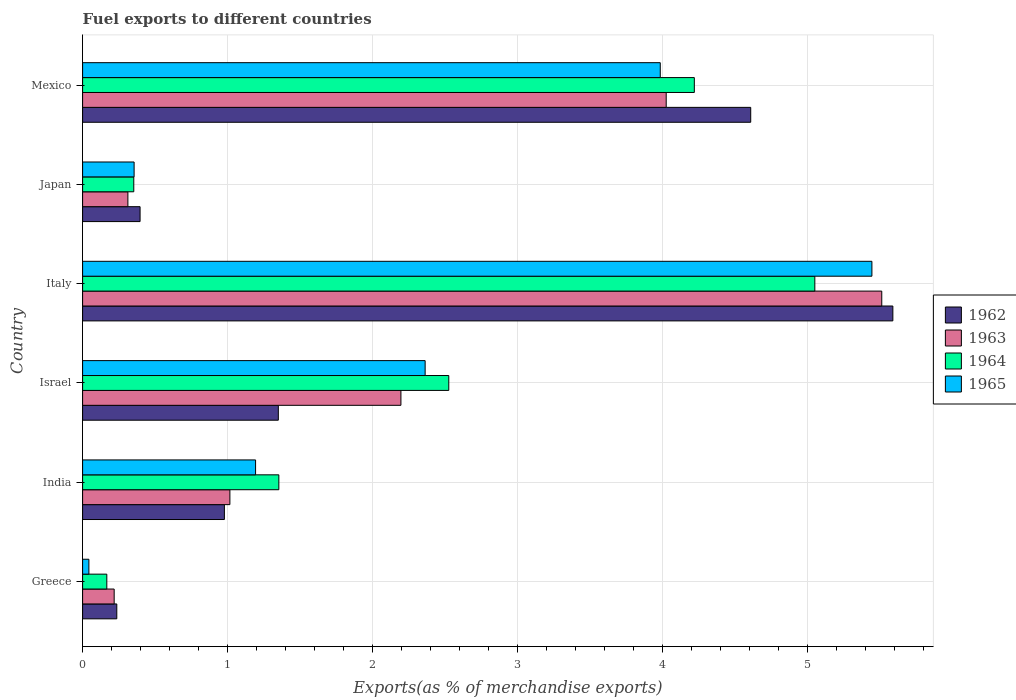How many different coloured bars are there?
Offer a very short reply. 4. How many groups of bars are there?
Offer a terse response. 6. Are the number of bars per tick equal to the number of legend labels?
Your response must be concise. Yes. How many bars are there on the 4th tick from the top?
Make the answer very short. 4. What is the label of the 1st group of bars from the top?
Offer a terse response. Mexico. In how many cases, is the number of bars for a given country not equal to the number of legend labels?
Your answer should be very brief. 0. What is the percentage of exports to different countries in 1965 in Japan?
Give a very brief answer. 0.36. Across all countries, what is the maximum percentage of exports to different countries in 1963?
Keep it short and to the point. 5.51. Across all countries, what is the minimum percentage of exports to different countries in 1964?
Your answer should be compact. 0.17. In which country was the percentage of exports to different countries in 1964 maximum?
Your answer should be very brief. Italy. What is the total percentage of exports to different countries in 1963 in the graph?
Give a very brief answer. 13.28. What is the difference between the percentage of exports to different countries in 1963 in Israel and that in Japan?
Your answer should be very brief. 1.88. What is the difference between the percentage of exports to different countries in 1962 in Italy and the percentage of exports to different countries in 1965 in Mexico?
Provide a succinct answer. 1.6. What is the average percentage of exports to different countries in 1962 per country?
Your answer should be compact. 2.19. What is the difference between the percentage of exports to different countries in 1962 and percentage of exports to different countries in 1964 in India?
Ensure brevity in your answer.  -0.38. In how many countries, is the percentage of exports to different countries in 1963 greater than 5 %?
Your response must be concise. 1. What is the ratio of the percentage of exports to different countries in 1964 in India to that in Italy?
Give a very brief answer. 0.27. Is the difference between the percentage of exports to different countries in 1962 in Israel and Italy greater than the difference between the percentage of exports to different countries in 1964 in Israel and Italy?
Offer a very short reply. No. What is the difference between the highest and the second highest percentage of exports to different countries in 1962?
Offer a terse response. 0.98. What is the difference between the highest and the lowest percentage of exports to different countries in 1964?
Provide a succinct answer. 4.88. Is the sum of the percentage of exports to different countries in 1965 in India and Japan greater than the maximum percentage of exports to different countries in 1963 across all countries?
Provide a succinct answer. No. What does the 2nd bar from the top in Japan represents?
Your answer should be very brief. 1964. What does the 4th bar from the bottom in Italy represents?
Offer a terse response. 1965. Is it the case that in every country, the sum of the percentage of exports to different countries in 1965 and percentage of exports to different countries in 1963 is greater than the percentage of exports to different countries in 1962?
Provide a succinct answer. Yes. How many bars are there?
Make the answer very short. 24. Are all the bars in the graph horizontal?
Offer a very short reply. Yes. How many countries are there in the graph?
Your response must be concise. 6. What is the difference between two consecutive major ticks on the X-axis?
Make the answer very short. 1. Are the values on the major ticks of X-axis written in scientific E-notation?
Offer a very short reply. No. Does the graph contain any zero values?
Make the answer very short. No. Does the graph contain grids?
Keep it short and to the point. Yes. What is the title of the graph?
Your response must be concise. Fuel exports to different countries. What is the label or title of the X-axis?
Ensure brevity in your answer.  Exports(as % of merchandise exports). What is the Exports(as % of merchandise exports) of 1962 in Greece?
Give a very brief answer. 0.24. What is the Exports(as % of merchandise exports) of 1963 in Greece?
Give a very brief answer. 0.22. What is the Exports(as % of merchandise exports) of 1964 in Greece?
Keep it short and to the point. 0.17. What is the Exports(as % of merchandise exports) in 1965 in Greece?
Offer a very short reply. 0.04. What is the Exports(as % of merchandise exports) in 1962 in India?
Your response must be concise. 0.98. What is the Exports(as % of merchandise exports) of 1963 in India?
Provide a short and direct response. 1.02. What is the Exports(as % of merchandise exports) of 1964 in India?
Keep it short and to the point. 1.35. What is the Exports(as % of merchandise exports) in 1965 in India?
Offer a very short reply. 1.19. What is the Exports(as % of merchandise exports) in 1962 in Israel?
Make the answer very short. 1.35. What is the Exports(as % of merchandise exports) of 1963 in Israel?
Make the answer very short. 2.2. What is the Exports(as % of merchandise exports) in 1964 in Israel?
Ensure brevity in your answer.  2.53. What is the Exports(as % of merchandise exports) of 1965 in Israel?
Give a very brief answer. 2.36. What is the Exports(as % of merchandise exports) in 1962 in Italy?
Your answer should be compact. 5.59. What is the Exports(as % of merchandise exports) of 1963 in Italy?
Your response must be concise. 5.51. What is the Exports(as % of merchandise exports) of 1964 in Italy?
Make the answer very short. 5.05. What is the Exports(as % of merchandise exports) of 1965 in Italy?
Give a very brief answer. 5.45. What is the Exports(as % of merchandise exports) in 1962 in Japan?
Ensure brevity in your answer.  0.4. What is the Exports(as % of merchandise exports) in 1963 in Japan?
Your answer should be very brief. 0.31. What is the Exports(as % of merchandise exports) of 1964 in Japan?
Keep it short and to the point. 0.35. What is the Exports(as % of merchandise exports) of 1965 in Japan?
Make the answer very short. 0.36. What is the Exports(as % of merchandise exports) in 1962 in Mexico?
Provide a succinct answer. 4.61. What is the Exports(as % of merchandise exports) in 1963 in Mexico?
Offer a very short reply. 4.03. What is the Exports(as % of merchandise exports) in 1964 in Mexico?
Your response must be concise. 4.22. What is the Exports(as % of merchandise exports) in 1965 in Mexico?
Provide a short and direct response. 3.99. Across all countries, what is the maximum Exports(as % of merchandise exports) of 1962?
Keep it short and to the point. 5.59. Across all countries, what is the maximum Exports(as % of merchandise exports) in 1963?
Offer a terse response. 5.51. Across all countries, what is the maximum Exports(as % of merchandise exports) of 1964?
Your answer should be very brief. 5.05. Across all countries, what is the maximum Exports(as % of merchandise exports) of 1965?
Your answer should be very brief. 5.45. Across all countries, what is the minimum Exports(as % of merchandise exports) of 1962?
Offer a terse response. 0.24. Across all countries, what is the minimum Exports(as % of merchandise exports) of 1963?
Offer a very short reply. 0.22. Across all countries, what is the minimum Exports(as % of merchandise exports) of 1964?
Provide a succinct answer. 0.17. Across all countries, what is the minimum Exports(as % of merchandise exports) in 1965?
Your answer should be very brief. 0.04. What is the total Exports(as % of merchandise exports) in 1962 in the graph?
Provide a succinct answer. 13.16. What is the total Exports(as % of merchandise exports) of 1963 in the graph?
Your response must be concise. 13.28. What is the total Exports(as % of merchandise exports) in 1964 in the graph?
Ensure brevity in your answer.  13.67. What is the total Exports(as % of merchandise exports) of 1965 in the graph?
Your answer should be very brief. 13.39. What is the difference between the Exports(as % of merchandise exports) in 1962 in Greece and that in India?
Provide a short and direct response. -0.74. What is the difference between the Exports(as % of merchandise exports) of 1963 in Greece and that in India?
Keep it short and to the point. -0.8. What is the difference between the Exports(as % of merchandise exports) of 1964 in Greece and that in India?
Your response must be concise. -1.19. What is the difference between the Exports(as % of merchandise exports) in 1965 in Greece and that in India?
Your answer should be compact. -1.15. What is the difference between the Exports(as % of merchandise exports) of 1962 in Greece and that in Israel?
Offer a terse response. -1.11. What is the difference between the Exports(as % of merchandise exports) of 1963 in Greece and that in Israel?
Give a very brief answer. -1.98. What is the difference between the Exports(as % of merchandise exports) of 1964 in Greece and that in Israel?
Give a very brief answer. -2.36. What is the difference between the Exports(as % of merchandise exports) in 1965 in Greece and that in Israel?
Make the answer very short. -2.32. What is the difference between the Exports(as % of merchandise exports) of 1962 in Greece and that in Italy?
Offer a terse response. -5.35. What is the difference between the Exports(as % of merchandise exports) in 1963 in Greece and that in Italy?
Provide a succinct answer. -5.3. What is the difference between the Exports(as % of merchandise exports) in 1964 in Greece and that in Italy?
Give a very brief answer. -4.88. What is the difference between the Exports(as % of merchandise exports) in 1965 in Greece and that in Italy?
Your answer should be very brief. -5.4. What is the difference between the Exports(as % of merchandise exports) of 1962 in Greece and that in Japan?
Keep it short and to the point. -0.16. What is the difference between the Exports(as % of merchandise exports) in 1963 in Greece and that in Japan?
Ensure brevity in your answer.  -0.09. What is the difference between the Exports(as % of merchandise exports) of 1964 in Greece and that in Japan?
Keep it short and to the point. -0.19. What is the difference between the Exports(as % of merchandise exports) in 1965 in Greece and that in Japan?
Your answer should be very brief. -0.31. What is the difference between the Exports(as % of merchandise exports) in 1962 in Greece and that in Mexico?
Offer a terse response. -4.37. What is the difference between the Exports(as % of merchandise exports) in 1963 in Greece and that in Mexico?
Offer a terse response. -3.81. What is the difference between the Exports(as % of merchandise exports) of 1964 in Greece and that in Mexico?
Offer a very short reply. -4.05. What is the difference between the Exports(as % of merchandise exports) in 1965 in Greece and that in Mexico?
Keep it short and to the point. -3.94. What is the difference between the Exports(as % of merchandise exports) of 1962 in India and that in Israel?
Ensure brevity in your answer.  -0.37. What is the difference between the Exports(as % of merchandise exports) in 1963 in India and that in Israel?
Offer a very short reply. -1.18. What is the difference between the Exports(as % of merchandise exports) of 1964 in India and that in Israel?
Your answer should be very brief. -1.17. What is the difference between the Exports(as % of merchandise exports) of 1965 in India and that in Israel?
Your response must be concise. -1.17. What is the difference between the Exports(as % of merchandise exports) of 1962 in India and that in Italy?
Your response must be concise. -4.61. What is the difference between the Exports(as % of merchandise exports) in 1963 in India and that in Italy?
Give a very brief answer. -4.5. What is the difference between the Exports(as % of merchandise exports) of 1964 in India and that in Italy?
Your response must be concise. -3.7. What is the difference between the Exports(as % of merchandise exports) of 1965 in India and that in Italy?
Offer a terse response. -4.25. What is the difference between the Exports(as % of merchandise exports) in 1962 in India and that in Japan?
Your response must be concise. 0.58. What is the difference between the Exports(as % of merchandise exports) in 1963 in India and that in Japan?
Your answer should be very brief. 0.7. What is the difference between the Exports(as % of merchandise exports) of 1965 in India and that in Japan?
Give a very brief answer. 0.84. What is the difference between the Exports(as % of merchandise exports) in 1962 in India and that in Mexico?
Offer a terse response. -3.63. What is the difference between the Exports(as % of merchandise exports) of 1963 in India and that in Mexico?
Your response must be concise. -3.01. What is the difference between the Exports(as % of merchandise exports) in 1964 in India and that in Mexico?
Keep it short and to the point. -2.87. What is the difference between the Exports(as % of merchandise exports) in 1965 in India and that in Mexico?
Your response must be concise. -2.79. What is the difference between the Exports(as % of merchandise exports) in 1962 in Israel and that in Italy?
Give a very brief answer. -4.24. What is the difference between the Exports(as % of merchandise exports) in 1963 in Israel and that in Italy?
Keep it short and to the point. -3.32. What is the difference between the Exports(as % of merchandise exports) in 1964 in Israel and that in Italy?
Offer a terse response. -2.53. What is the difference between the Exports(as % of merchandise exports) in 1965 in Israel and that in Italy?
Keep it short and to the point. -3.08. What is the difference between the Exports(as % of merchandise exports) in 1962 in Israel and that in Japan?
Your response must be concise. 0.95. What is the difference between the Exports(as % of merchandise exports) in 1963 in Israel and that in Japan?
Provide a succinct answer. 1.88. What is the difference between the Exports(as % of merchandise exports) in 1964 in Israel and that in Japan?
Offer a terse response. 2.17. What is the difference between the Exports(as % of merchandise exports) of 1965 in Israel and that in Japan?
Your response must be concise. 2.01. What is the difference between the Exports(as % of merchandise exports) of 1962 in Israel and that in Mexico?
Your answer should be very brief. -3.26. What is the difference between the Exports(as % of merchandise exports) of 1963 in Israel and that in Mexico?
Offer a terse response. -1.83. What is the difference between the Exports(as % of merchandise exports) in 1964 in Israel and that in Mexico?
Your response must be concise. -1.69. What is the difference between the Exports(as % of merchandise exports) in 1965 in Israel and that in Mexico?
Offer a very short reply. -1.62. What is the difference between the Exports(as % of merchandise exports) of 1962 in Italy and that in Japan?
Provide a short and direct response. 5.19. What is the difference between the Exports(as % of merchandise exports) in 1963 in Italy and that in Japan?
Your response must be concise. 5.2. What is the difference between the Exports(as % of merchandise exports) in 1964 in Italy and that in Japan?
Make the answer very short. 4.7. What is the difference between the Exports(as % of merchandise exports) of 1965 in Italy and that in Japan?
Ensure brevity in your answer.  5.09. What is the difference between the Exports(as % of merchandise exports) in 1962 in Italy and that in Mexico?
Keep it short and to the point. 0.98. What is the difference between the Exports(as % of merchandise exports) of 1963 in Italy and that in Mexico?
Your answer should be compact. 1.49. What is the difference between the Exports(as % of merchandise exports) of 1964 in Italy and that in Mexico?
Make the answer very short. 0.83. What is the difference between the Exports(as % of merchandise exports) in 1965 in Italy and that in Mexico?
Provide a succinct answer. 1.46. What is the difference between the Exports(as % of merchandise exports) of 1962 in Japan and that in Mexico?
Provide a succinct answer. -4.21. What is the difference between the Exports(as % of merchandise exports) in 1963 in Japan and that in Mexico?
Provide a succinct answer. -3.71. What is the difference between the Exports(as % of merchandise exports) of 1964 in Japan and that in Mexico?
Your answer should be compact. -3.87. What is the difference between the Exports(as % of merchandise exports) of 1965 in Japan and that in Mexico?
Offer a terse response. -3.63. What is the difference between the Exports(as % of merchandise exports) in 1962 in Greece and the Exports(as % of merchandise exports) in 1963 in India?
Your answer should be compact. -0.78. What is the difference between the Exports(as % of merchandise exports) of 1962 in Greece and the Exports(as % of merchandise exports) of 1964 in India?
Provide a short and direct response. -1.12. What is the difference between the Exports(as % of merchandise exports) of 1962 in Greece and the Exports(as % of merchandise exports) of 1965 in India?
Offer a very short reply. -0.96. What is the difference between the Exports(as % of merchandise exports) of 1963 in Greece and the Exports(as % of merchandise exports) of 1964 in India?
Offer a very short reply. -1.14. What is the difference between the Exports(as % of merchandise exports) of 1963 in Greece and the Exports(as % of merchandise exports) of 1965 in India?
Your response must be concise. -0.98. What is the difference between the Exports(as % of merchandise exports) in 1964 in Greece and the Exports(as % of merchandise exports) in 1965 in India?
Offer a terse response. -1.03. What is the difference between the Exports(as % of merchandise exports) of 1962 in Greece and the Exports(as % of merchandise exports) of 1963 in Israel?
Provide a short and direct response. -1.96. What is the difference between the Exports(as % of merchandise exports) of 1962 in Greece and the Exports(as % of merchandise exports) of 1964 in Israel?
Your answer should be very brief. -2.29. What is the difference between the Exports(as % of merchandise exports) of 1962 in Greece and the Exports(as % of merchandise exports) of 1965 in Israel?
Provide a short and direct response. -2.13. What is the difference between the Exports(as % of merchandise exports) of 1963 in Greece and the Exports(as % of merchandise exports) of 1964 in Israel?
Give a very brief answer. -2.31. What is the difference between the Exports(as % of merchandise exports) in 1963 in Greece and the Exports(as % of merchandise exports) in 1965 in Israel?
Keep it short and to the point. -2.15. What is the difference between the Exports(as % of merchandise exports) in 1964 in Greece and the Exports(as % of merchandise exports) in 1965 in Israel?
Your answer should be compact. -2.2. What is the difference between the Exports(as % of merchandise exports) of 1962 in Greece and the Exports(as % of merchandise exports) of 1963 in Italy?
Ensure brevity in your answer.  -5.28. What is the difference between the Exports(as % of merchandise exports) of 1962 in Greece and the Exports(as % of merchandise exports) of 1964 in Italy?
Offer a very short reply. -4.82. What is the difference between the Exports(as % of merchandise exports) in 1962 in Greece and the Exports(as % of merchandise exports) in 1965 in Italy?
Your response must be concise. -5.21. What is the difference between the Exports(as % of merchandise exports) of 1963 in Greece and the Exports(as % of merchandise exports) of 1964 in Italy?
Provide a short and direct response. -4.83. What is the difference between the Exports(as % of merchandise exports) in 1963 in Greece and the Exports(as % of merchandise exports) in 1965 in Italy?
Make the answer very short. -5.23. What is the difference between the Exports(as % of merchandise exports) in 1964 in Greece and the Exports(as % of merchandise exports) in 1965 in Italy?
Your answer should be very brief. -5.28. What is the difference between the Exports(as % of merchandise exports) in 1962 in Greece and the Exports(as % of merchandise exports) in 1963 in Japan?
Ensure brevity in your answer.  -0.08. What is the difference between the Exports(as % of merchandise exports) of 1962 in Greece and the Exports(as % of merchandise exports) of 1964 in Japan?
Your answer should be very brief. -0.12. What is the difference between the Exports(as % of merchandise exports) in 1962 in Greece and the Exports(as % of merchandise exports) in 1965 in Japan?
Keep it short and to the point. -0.12. What is the difference between the Exports(as % of merchandise exports) in 1963 in Greece and the Exports(as % of merchandise exports) in 1964 in Japan?
Keep it short and to the point. -0.14. What is the difference between the Exports(as % of merchandise exports) of 1963 in Greece and the Exports(as % of merchandise exports) of 1965 in Japan?
Your answer should be compact. -0.14. What is the difference between the Exports(as % of merchandise exports) of 1964 in Greece and the Exports(as % of merchandise exports) of 1965 in Japan?
Ensure brevity in your answer.  -0.19. What is the difference between the Exports(as % of merchandise exports) in 1962 in Greece and the Exports(as % of merchandise exports) in 1963 in Mexico?
Give a very brief answer. -3.79. What is the difference between the Exports(as % of merchandise exports) of 1962 in Greece and the Exports(as % of merchandise exports) of 1964 in Mexico?
Provide a short and direct response. -3.98. What is the difference between the Exports(as % of merchandise exports) in 1962 in Greece and the Exports(as % of merchandise exports) in 1965 in Mexico?
Make the answer very short. -3.75. What is the difference between the Exports(as % of merchandise exports) in 1963 in Greece and the Exports(as % of merchandise exports) in 1964 in Mexico?
Offer a terse response. -4. What is the difference between the Exports(as % of merchandise exports) in 1963 in Greece and the Exports(as % of merchandise exports) in 1965 in Mexico?
Your response must be concise. -3.77. What is the difference between the Exports(as % of merchandise exports) in 1964 in Greece and the Exports(as % of merchandise exports) in 1965 in Mexico?
Offer a terse response. -3.82. What is the difference between the Exports(as % of merchandise exports) of 1962 in India and the Exports(as % of merchandise exports) of 1963 in Israel?
Provide a succinct answer. -1.22. What is the difference between the Exports(as % of merchandise exports) in 1962 in India and the Exports(as % of merchandise exports) in 1964 in Israel?
Offer a terse response. -1.55. What is the difference between the Exports(as % of merchandise exports) in 1962 in India and the Exports(as % of merchandise exports) in 1965 in Israel?
Offer a very short reply. -1.38. What is the difference between the Exports(as % of merchandise exports) of 1963 in India and the Exports(as % of merchandise exports) of 1964 in Israel?
Make the answer very short. -1.51. What is the difference between the Exports(as % of merchandise exports) in 1963 in India and the Exports(as % of merchandise exports) in 1965 in Israel?
Your answer should be compact. -1.35. What is the difference between the Exports(as % of merchandise exports) in 1964 in India and the Exports(as % of merchandise exports) in 1965 in Israel?
Provide a short and direct response. -1.01. What is the difference between the Exports(as % of merchandise exports) in 1962 in India and the Exports(as % of merchandise exports) in 1963 in Italy?
Your answer should be compact. -4.54. What is the difference between the Exports(as % of merchandise exports) of 1962 in India and the Exports(as % of merchandise exports) of 1964 in Italy?
Offer a very short reply. -4.07. What is the difference between the Exports(as % of merchandise exports) of 1962 in India and the Exports(as % of merchandise exports) of 1965 in Italy?
Ensure brevity in your answer.  -4.47. What is the difference between the Exports(as % of merchandise exports) in 1963 in India and the Exports(as % of merchandise exports) in 1964 in Italy?
Your response must be concise. -4.04. What is the difference between the Exports(as % of merchandise exports) in 1963 in India and the Exports(as % of merchandise exports) in 1965 in Italy?
Provide a short and direct response. -4.43. What is the difference between the Exports(as % of merchandise exports) of 1964 in India and the Exports(as % of merchandise exports) of 1965 in Italy?
Offer a terse response. -4.09. What is the difference between the Exports(as % of merchandise exports) in 1962 in India and the Exports(as % of merchandise exports) in 1963 in Japan?
Provide a succinct answer. 0.67. What is the difference between the Exports(as % of merchandise exports) of 1962 in India and the Exports(as % of merchandise exports) of 1964 in Japan?
Offer a very short reply. 0.63. What is the difference between the Exports(as % of merchandise exports) of 1962 in India and the Exports(as % of merchandise exports) of 1965 in Japan?
Offer a very short reply. 0.62. What is the difference between the Exports(as % of merchandise exports) in 1963 in India and the Exports(as % of merchandise exports) in 1964 in Japan?
Your response must be concise. 0.66. What is the difference between the Exports(as % of merchandise exports) in 1963 in India and the Exports(as % of merchandise exports) in 1965 in Japan?
Your answer should be compact. 0.66. What is the difference between the Exports(as % of merchandise exports) of 1962 in India and the Exports(as % of merchandise exports) of 1963 in Mexico?
Your answer should be very brief. -3.05. What is the difference between the Exports(as % of merchandise exports) of 1962 in India and the Exports(as % of merchandise exports) of 1964 in Mexico?
Keep it short and to the point. -3.24. What is the difference between the Exports(as % of merchandise exports) in 1962 in India and the Exports(as % of merchandise exports) in 1965 in Mexico?
Offer a very short reply. -3.01. What is the difference between the Exports(as % of merchandise exports) in 1963 in India and the Exports(as % of merchandise exports) in 1964 in Mexico?
Give a very brief answer. -3.2. What is the difference between the Exports(as % of merchandise exports) of 1963 in India and the Exports(as % of merchandise exports) of 1965 in Mexico?
Ensure brevity in your answer.  -2.97. What is the difference between the Exports(as % of merchandise exports) of 1964 in India and the Exports(as % of merchandise exports) of 1965 in Mexico?
Provide a short and direct response. -2.63. What is the difference between the Exports(as % of merchandise exports) in 1962 in Israel and the Exports(as % of merchandise exports) in 1963 in Italy?
Your response must be concise. -4.16. What is the difference between the Exports(as % of merchandise exports) of 1962 in Israel and the Exports(as % of merchandise exports) of 1964 in Italy?
Your answer should be very brief. -3.7. What is the difference between the Exports(as % of merchandise exports) in 1962 in Israel and the Exports(as % of merchandise exports) in 1965 in Italy?
Your response must be concise. -4.09. What is the difference between the Exports(as % of merchandise exports) of 1963 in Israel and the Exports(as % of merchandise exports) of 1964 in Italy?
Provide a succinct answer. -2.86. What is the difference between the Exports(as % of merchandise exports) of 1963 in Israel and the Exports(as % of merchandise exports) of 1965 in Italy?
Provide a succinct answer. -3.25. What is the difference between the Exports(as % of merchandise exports) in 1964 in Israel and the Exports(as % of merchandise exports) in 1965 in Italy?
Ensure brevity in your answer.  -2.92. What is the difference between the Exports(as % of merchandise exports) in 1962 in Israel and the Exports(as % of merchandise exports) in 1963 in Japan?
Your answer should be compact. 1.04. What is the difference between the Exports(as % of merchandise exports) in 1962 in Israel and the Exports(as % of merchandise exports) in 1965 in Japan?
Your answer should be compact. 0.99. What is the difference between the Exports(as % of merchandise exports) in 1963 in Israel and the Exports(as % of merchandise exports) in 1964 in Japan?
Give a very brief answer. 1.84. What is the difference between the Exports(as % of merchandise exports) in 1963 in Israel and the Exports(as % of merchandise exports) in 1965 in Japan?
Make the answer very short. 1.84. What is the difference between the Exports(as % of merchandise exports) in 1964 in Israel and the Exports(as % of merchandise exports) in 1965 in Japan?
Ensure brevity in your answer.  2.17. What is the difference between the Exports(as % of merchandise exports) in 1962 in Israel and the Exports(as % of merchandise exports) in 1963 in Mexico?
Your answer should be compact. -2.68. What is the difference between the Exports(as % of merchandise exports) of 1962 in Israel and the Exports(as % of merchandise exports) of 1964 in Mexico?
Give a very brief answer. -2.87. What is the difference between the Exports(as % of merchandise exports) of 1962 in Israel and the Exports(as % of merchandise exports) of 1965 in Mexico?
Provide a short and direct response. -2.63. What is the difference between the Exports(as % of merchandise exports) of 1963 in Israel and the Exports(as % of merchandise exports) of 1964 in Mexico?
Provide a short and direct response. -2.02. What is the difference between the Exports(as % of merchandise exports) in 1963 in Israel and the Exports(as % of merchandise exports) in 1965 in Mexico?
Ensure brevity in your answer.  -1.79. What is the difference between the Exports(as % of merchandise exports) of 1964 in Israel and the Exports(as % of merchandise exports) of 1965 in Mexico?
Make the answer very short. -1.46. What is the difference between the Exports(as % of merchandise exports) of 1962 in Italy and the Exports(as % of merchandise exports) of 1963 in Japan?
Your answer should be very brief. 5.28. What is the difference between the Exports(as % of merchandise exports) in 1962 in Italy and the Exports(as % of merchandise exports) in 1964 in Japan?
Provide a short and direct response. 5.24. What is the difference between the Exports(as % of merchandise exports) of 1962 in Italy and the Exports(as % of merchandise exports) of 1965 in Japan?
Provide a short and direct response. 5.23. What is the difference between the Exports(as % of merchandise exports) in 1963 in Italy and the Exports(as % of merchandise exports) in 1964 in Japan?
Your response must be concise. 5.16. What is the difference between the Exports(as % of merchandise exports) in 1963 in Italy and the Exports(as % of merchandise exports) in 1965 in Japan?
Offer a terse response. 5.16. What is the difference between the Exports(as % of merchandise exports) of 1964 in Italy and the Exports(as % of merchandise exports) of 1965 in Japan?
Give a very brief answer. 4.7. What is the difference between the Exports(as % of merchandise exports) of 1962 in Italy and the Exports(as % of merchandise exports) of 1963 in Mexico?
Provide a short and direct response. 1.56. What is the difference between the Exports(as % of merchandise exports) of 1962 in Italy and the Exports(as % of merchandise exports) of 1964 in Mexico?
Your response must be concise. 1.37. What is the difference between the Exports(as % of merchandise exports) in 1962 in Italy and the Exports(as % of merchandise exports) in 1965 in Mexico?
Keep it short and to the point. 1.6. What is the difference between the Exports(as % of merchandise exports) in 1963 in Italy and the Exports(as % of merchandise exports) in 1964 in Mexico?
Offer a very short reply. 1.29. What is the difference between the Exports(as % of merchandise exports) in 1963 in Italy and the Exports(as % of merchandise exports) in 1965 in Mexico?
Your response must be concise. 1.53. What is the difference between the Exports(as % of merchandise exports) in 1964 in Italy and the Exports(as % of merchandise exports) in 1965 in Mexico?
Provide a short and direct response. 1.07. What is the difference between the Exports(as % of merchandise exports) in 1962 in Japan and the Exports(as % of merchandise exports) in 1963 in Mexico?
Make the answer very short. -3.63. What is the difference between the Exports(as % of merchandise exports) in 1962 in Japan and the Exports(as % of merchandise exports) in 1964 in Mexico?
Offer a very short reply. -3.82. What is the difference between the Exports(as % of merchandise exports) of 1962 in Japan and the Exports(as % of merchandise exports) of 1965 in Mexico?
Make the answer very short. -3.59. What is the difference between the Exports(as % of merchandise exports) in 1963 in Japan and the Exports(as % of merchandise exports) in 1964 in Mexico?
Ensure brevity in your answer.  -3.91. What is the difference between the Exports(as % of merchandise exports) in 1963 in Japan and the Exports(as % of merchandise exports) in 1965 in Mexico?
Provide a succinct answer. -3.67. What is the difference between the Exports(as % of merchandise exports) of 1964 in Japan and the Exports(as % of merchandise exports) of 1965 in Mexico?
Your answer should be very brief. -3.63. What is the average Exports(as % of merchandise exports) in 1962 per country?
Provide a short and direct response. 2.19. What is the average Exports(as % of merchandise exports) of 1963 per country?
Ensure brevity in your answer.  2.21. What is the average Exports(as % of merchandise exports) in 1964 per country?
Give a very brief answer. 2.28. What is the average Exports(as % of merchandise exports) of 1965 per country?
Provide a short and direct response. 2.23. What is the difference between the Exports(as % of merchandise exports) of 1962 and Exports(as % of merchandise exports) of 1963 in Greece?
Keep it short and to the point. 0.02. What is the difference between the Exports(as % of merchandise exports) of 1962 and Exports(as % of merchandise exports) of 1964 in Greece?
Keep it short and to the point. 0.07. What is the difference between the Exports(as % of merchandise exports) in 1962 and Exports(as % of merchandise exports) in 1965 in Greece?
Make the answer very short. 0.19. What is the difference between the Exports(as % of merchandise exports) of 1963 and Exports(as % of merchandise exports) of 1964 in Greece?
Offer a terse response. 0.05. What is the difference between the Exports(as % of merchandise exports) in 1963 and Exports(as % of merchandise exports) in 1965 in Greece?
Provide a succinct answer. 0.17. What is the difference between the Exports(as % of merchandise exports) in 1964 and Exports(as % of merchandise exports) in 1965 in Greece?
Offer a very short reply. 0.12. What is the difference between the Exports(as % of merchandise exports) in 1962 and Exports(as % of merchandise exports) in 1963 in India?
Provide a short and direct response. -0.04. What is the difference between the Exports(as % of merchandise exports) in 1962 and Exports(as % of merchandise exports) in 1964 in India?
Keep it short and to the point. -0.38. What is the difference between the Exports(as % of merchandise exports) of 1962 and Exports(as % of merchandise exports) of 1965 in India?
Keep it short and to the point. -0.22. What is the difference between the Exports(as % of merchandise exports) in 1963 and Exports(as % of merchandise exports) in 1964 in India?
Provide a succinct answer. -0.34. What is the difference between the Exports(as % of merchandise exports) of 1963 and Exports(as % of merchandise exports) of 1965 in India?
Your response must be concise. -0.18. What is the difference between the Exports(as % of merchandise exports) in 1964 and Exports(as % of merchandise exports) in 1965 in India?
Keep it short and to the point. 0.16. What is the difference between the Exports(as % of merchandise exports) of 1962 and Exports(as % of merchandise exports) of 1963 in Israel?
Make the answer very short. -0.85. What is the difference between the Exports(as % of merchandise exports) of 1962 and Exports(as % of merchandise exports) of 1964 in Israel?
Offer a very short reply. -1.18. What is the difference between the Exports(as % of merchandise exports) in 1962 and Exports(as % of merchandise exports) in 1965 in Israel?
Give a very brief answer. -1.01. What is the difference between the Exports(as % of merchandise exports) in 1963 and Exports(as % of merchandise exports) in 1964 in Israel?
Offer a very short reply. -0.33. What is the difference between the Exports(as % of merchandise exports) in 1963 and Exports(as % of merchandise exports) in 1965 in Israel?
Provide a succinct answer. -0.17. What is the difference between the Exports(as % of merchandise exports) of 1964 and Exports(as % of merchandise exports) of 1965 in Israel?
Offer a very short reply. 0.16. What is the difference between the Exports(as % of merchandise exports) in 1962 and Exports(as % of merchandise exports) in 1963 in Italy?
Keep it short and to the point. 0.08. What is the difference between the Exports(as % of merchandise exports) of 1962 and Exports(as % of merchandise exports) of 1964 in Italy?
Your response must be concise. 0.54. What is the difference between the Exports(as % of merchandise exports) in 1962 and Exports(as % of merchandise exports) in 1965 in Italy?
Keep it short and to the point. 0.14. What is the difference between the Exports(as % of merchandise exports) in 1963 and Exports(as % of merchandise exports) in 1964 in Italy?
Give a very brief answer. 0.46. What is the difference between the Exports(as % of merchandise exports) of 1963 and Exports(as % of merchandise exports) of 1965 in Italy?
Provide a short and direct response. 0.07. What is the difference between the Exports(as % of merchandise exports) in 1964 and Exports(as % of merchandise exports) in 1965 in Italy?
Your answer should be compact. -0.39. What is the difference between the Exports(as % of merchandise exports) of 1962 and Exports(as % of merchandise exports) of 1963 in Japan?
Provide a short and direct response. 0.08. What is the difference between the Exports(as % of merchandise exports) in 1962 and Exports(as % of merchandise exports) in 1964 in Japan?
Offer a very short reply. 0.04. What is the difference between the Exports(as % of merchandise exports) in 1962 and Exports(as % of merchandise exports) in 1965 in Japan?
Ensure brevity in your answer.  0.04. What is the difference between the Exports(as % of merchandise exports) of 1963 and Exports(as % of merchandise exports) of 1964 in Japan?
Make the answer very short. -0.04. What is the difference between the Exports(as % of merchandise exports) of 1963 and Exports(as % of merchandise exports) of 1965 in Japan?
Make the answer very short. -0.04. What is the difference between the Exports(as % of merchandise exports) of 1964 and Exports(as % of merchandise exports) of 1965 in Japan?
Give a very brief answer. -0. What is the difference between the Exports(as % of merchandise exports) in 1962 and Exports(as % of merchandise exports) in 1963 in Mexico?
Ensure brevity in your answer.  0.58. What is the difference between the Exports(as % of merchandise exports) in 1962 and Exports(as % of merchandise exports) in 1964 in Mexico?
Give a very brief answer. 0.39. What is the difference between the Exports(as % of merchandise exports) of 1962 and Exports(as % of merchandise exports) of 1965 in Mexico?
Your response must be concise. 0.62. What is the difference between the Exports(as % of merchandise exports) of 1963 and Exports(as % of merchandise exports) of 1964 in Mexico?
Give a very brief answer. -0.19. What is the difference between the Exports(as % of merchandise exports) of 1963 and Exports(as % of merchandise exports) of 1965 in Mexico?
Offer a terse response. 0.04. What is the difference between the Exports(as % of merchandise exports) of 1964 and Exports(as % of merchandise exports) of 1965 in Mexico?
Give a very brief answer. 0.23. What is the ratio of the Exports(as % of merchandise exports) in 1962 in Greece to that in India?
Your answer should be compact. 0.24. What is the ratio of the Exports(as % of merchandise exports) of 1963 in Greece to that in India?
Offer a very short reply. 0.21. What is the ratio of the Exports(as % of merchandise exports) of 1964 in Greece to that in India?
Provide a short and direct response. 0.12. What is the ratio of the Exports(as % of merchandise exports) in 1965 in Greece to that in India?
Ensure brevity in your answer.  0.04. What is the ratio of the Exports(as % of merchandise exports) in 1962 in Greece to that in Israel?
Your response must be concise. 0.17. What is the ratio of the Exports(as % of merchandise exports) of 1963 in Greece to that in Israel?
Keep it short and to the point. 0.1. What is the ratio of the Exports(as % of merchandise exports) of 1964 in Greece to that in Israel?
Your answer should be very brief. 0.07. What is the ratio of the Exports(as % of merchandise exports) of 1965 in Greece to that in Israel?
Provide a succinct answer. 0.02. What is the ratio of the Exports(as % of merchandise exports) in 1962 in Greece to that in Italy?
Your answer should be very brief. 0.04. What is the ratio of the Exports(as % of merchandise exports) of 1963 in Greece to that in Italy?
Make the answer very short. 0.04. What is the ratio of the Exports(as % of merchandise exports) of 1964 in Greece to that in Italy?
Offer a terse response. 0.03. What is the ratio of the Exports(as % of merchandise exports) of 1965 in Greece to that in Italy?
Provide a succinct answer. 0.01. What is the ratio of the Exports(as % of merchandise exports) in 1962 in Greece to that in Japan?
Keep it short and to the point. 0.59. What is the ratio of the Exports(as % of merchandise exports) of 1963 in Greece to that in Japan?
Your answer should be very brief. 0.7. What is the ratio of the Exports(as % of merchandise exports) in 1964 in Greece to that in Japan?
Keep it short and to the point. 0.47. What is the ratio of the Exports(as % of merchandise exports) in 1965 in Greece to that in Japan?
Provide a short and direct response. 0.12. What is the ratio of the Exports(as % of merchandise exports) in 1962 in Greece to that in Mexico?
Offer a very short reply. 0.05. What is the ratio of the Exports(as % of merchandise exports) in 1963 in Greece to that in Mexico?
Offer a terse response. 0.05. What is the ratio of the Exports(as % of merchandise exports) of 1964 in Greece to that in Mexico?
Make the answer very short. 0.04. What is the ratio of the Exports(as % of merchandise exports) of 1965 in Greece to that in Mexico?
Provide a short and direct response. 0.01. What is the ratio of the Exports(as % of merchandise exports) in 1962 in India to that in Israel?
Give a very brief answer. 0.72. What is the ratio of the Exports(as % of merchandise exports) of 1963 in India to that in Israel?
Provide a succinct answer. 0.46. What is the ratio of the Exports(as % of merchandise exports) in 1964 in India to that in Israel?
Keep it short and to the point. 0.54. What is the ratio of the Exports(as % of merchandise exports) of 1965 in India to that in Israel?
Provide a short and direct response. 0.51. What is the ratio of the Exports(as % of merchandise exports) of 1962 in India to that in Italy?
Ensure brevity in your answer.  0.17. What is the ratio of the Exports(as % of merchandise exports) in 1963 in India to that in Italy?
Ensure brevity in your answer.  0.18. What is the ratio of the Exports(as % of merchandise exports) of 1964 in India to that in Italy?
Offer a very short reply. 0.27. What is the ratio of the Exports(as % of merchandise exports) of 1965 in India to that in Italy?
Offer a very short reply. 0.22. What is the ratio of the Exports(as % of merchandise exports) of 1962 in India to that in Japan?
Provide a succinct answer. 2.47. What is the ratio of the Exports(as % of merchandise exports) in 1963 in India to that in Japan?
Provide a succinct answer. 3.25. What is the ratio of the Exports(as % of merchandise exports) in 1964 in India to that in Japan?
Offer a terse response. 3.83. What is the ratio of the Exports(as % of merchandise exports) of 1965 in India to that in Japan?
Give a very brief answer. 3.36. What is the ratio of the Exports(as % of merchandise exports) in 1962 in India to that in Mexico?
Ensure brevity in your answer.  0.21. What is the ratio of the Exports(as % of merchandise exports) of 1963 in India to that in Mexico?
Your answer should be very brief. 0.25. What is the ratio of the Exports(as % of merchandise exports) in 1964 in India to that in Mexico?
Ensure brevity in your answer.  0.32. What is the ratio of the Exports(as % of merchandise exports) in 1965 in India to that in Mexico?
Your response must be concise. 0.3. What is the ratio of the Exports(as % of merchandise exports) in 1962 in Israel to that in Italy?
Offer a very short reply. 0.24. What is the ratio of the Exports(as % of merchandise exports) of 1963 in Israel to that in Italy?
Ensure brevity in your answer.  0.4. What is the ratio of the Exports(as % of merchandise exports) in 1964 in Israel to that in Italy?
Make the answer very short. 0.5. What is the ratio of the Exports(as % of merchandise exports) in 1965 in Israel to that in Italy?
Keep it short and to the point. 0.43. What is the ratio of the Exports(as % of merchandise exports) of 1962 in Israel to that in Japan?
Give a very brief answer. 3.4. What is the ratio of the Exports(as % of merchandise exports) of 1963 in Israel to that in Japan?
Your answer should be very brief. 7.03. What is the ratio of the Exports(as % of merchandise exports) in 1964 in Israel to that in Japan?
Your answer should be very brief. 7.16. What is the ratio of the Exports(as % of merchandise exports) in 1965 in Israel to that in Japan?
Give a very brief answer. 6.65. What is the ratio of the Exports(as % of merchandise exports) in 1962 in Israel to that in Mexico?
Provide a short and direct response. 0.29. What is the ratio of the Exports(as % of merchandise exports) in 1963 in Israel to that in Mexico?
Your answer should be very brief. 0.55. What is the ratio of the Exports(as % of merchandise exports) of 1964 in Israel to that in Mexico?
Keep it short and to the point. 0.6. What is the ratio of the Exports(as % of merchandise exports) of 1965 in Israel to that in Mexico?
Offer a terse response. 0.59. What is the ratio of the Exports(as % of merchandise exports) in 1962 in Italy to that in Japan?
Make the answer very short. 14.1. What is the ratio of the Exports(as % of merchandise exports) of 1963 in Italy to that in Japan?
Provide a short and direct response. 17.64. What is the ratio of the Exports(as % of merchandise exports) in 1964 in Italy to that in Japan?
Keep it short and to the point. 14.31. What is the ratio of the Exports(as % of merchandise exports) in 1965 in Italy to that in Japan?
Make the answer very short. 15.32. What is the ratio of the Exports(as % of merchandise exports) in 1962 in Italy to that in Mexico?
Your answer should be compact. 1.21. What is the ratio of the Exports(as % of merchandise exports) of 1963 in Italy to that in Mexico?
Your response must be concise. 1.37. What is the ratio of the Exports(as % of merchandise exports) in 1964 in Italy to that in Mexico?
Keep it short and to the point. 1.2. What is the ratio of the Exports(as % of merchandise exports) of 1965 in Italy to that in Mexico?
Offer a terse response. 1.37. What is the ratio of the Exports(as % of merchandise exports) of 1962 in Japan to that in Mexico?
Provide a succinct answer. 0.09. What is the ratio of the Exports(as % of merchandise exports) in 1963 in Japan to that in Mexico?
Your answer should be very brief. 0.08. What is the ratio of the Exports(as % of merchandise exports) of 1964 in Japan to that in Mexico?
Give a very brief answer. 0.08. What is the ratio of the Exports(as % of merchandise exports) in 1965 in Japan to that in Mexico?
Provide a short and direct response. 0.09. What is the difference between the highest and the second highest Exports(as % of merchandise exports) of 1962?
Your answer should be very brief. 0.98. What is the difference between the highest and the second highest Exports(as % of merchandise exports) of 1963?
Make the answer very short. 1.49. What is the difference between the highest and the second highest Exports(as % of merchandise exports) in 1964?
Offer a very short reply. 0.83. What is the difference between the highest and the second highest Exports(as % of merchandise exports) of 1965?
Keep it short and to the point. 1.46. What is the difference between the highest and the lowest Exports(as % of merchandise exports) of 1962?
Your answer should be very brief. 5.35. What is the difference between the highest and the lowest Exports(as % of merchandise exports) of 1963?
Provide a succinct answer. 5.3. What is the difference between the highest and the lowest Exports(as % of merchandise exports) in 1964?
Offer a terse response. 4.88. What is the difference between the highest and the lowest Exports(as % of merchandise exports) of 1965?
Offer a terse response. 5.4. 